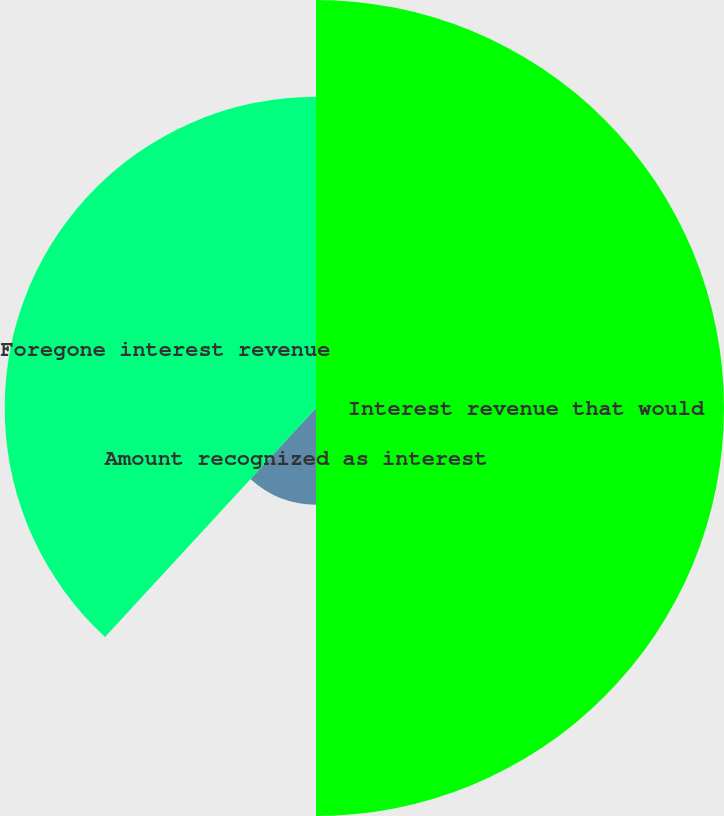Convert chart. <chart><loc_0><loc_0><loc_500><loc_500><pie_chart><fcel>Interest revenue that would<fcel>Amount recognized as interest<fcel>Foregone interest revenue<nl><fcel>50.0%<fcel>11.85%<fcel>38.15%<nl></chart> 